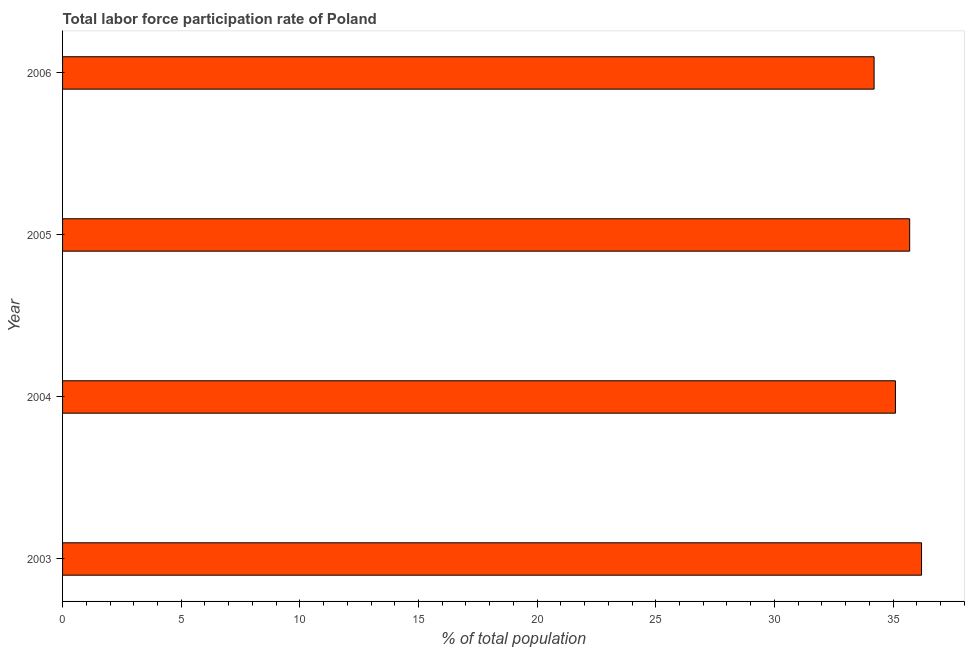Does the graph contain grids?
Offer a very short reply. No. What is the title of the graph?
Your answer should be compact. Total labor force participation rate of Poland. What is the label or title of the X-axis?
Your answer should be very brief. % of total population. What is the label or title of the Y-axis?
Your answer should be very brief. Year. What is the total labor force participation rate in 2003?
Offer a very short reply. 36.2. Across all years, what is the maximum total labor force participation rate?
Your response must be concise. 36.2. Across all years, what is the minimum total labor force participation rate?
Give a very brief answer. 34.2. In which year was the total labor force participation rate maximum?
Make the answer very short. 2003. What is the sum of the total labor force participation rate?
Make the answer very short. 141.2. What is the average total labor force participation rate per year?
Provide a succinct answer. 35.3. What is the median total labor force participation rate?
Provide a succinct answer. 35.4. Do a majority of the years between 2003 and 2005 (inclusive) have total labor force participation rate greater than 9 %?
Ensure brevity in your answer.  Yes. What is the ratio of the total labor force participation rate in 2005 to that in 2006?
Your answer should be very brief. 1.04. Is the total labor force participation rate in 2005 less than that in 2006?
Offer a terse response. No. Is the difference between the total labor force participation rate in 2003 and 2004 greater than the difference between any two years?
Provide a short and direct response. No. In how many years, is the total labor force participation rate greater than the average total labor force participation rate taken over all years?
Offer a terse response. 2. Are all the bars in the graph horizontal?
Offer a very short reply. Yes. What is the difference between two consecutive major ticks on the X-axis?
Offer a very short reply. 5. Are the values on the major ticks of X-axis written in scientific E-notation?
Keep it short and to the point. No. What is the % of total population of 2003?
Offer a very short reply. 36.2. What is the % of total population in 2004?
Ensure brevity in your answer.  35.1. What is the % of total population in 2005?
Ensure brevity in your answer.  35.7. What is the % of total population of 2006?
Your answer should be very brief. 34.2. What is the difference between the % of total population in 2003 and 2005?
Provide a short and direct response. 0.5. What is the difference between the % of total population in 2004 and 2005?
Your answer should be compact. -0.6. What is the difference between the % of total population in 2005 and 2006?
Ensure brevity in your answer.  1.5. What is the ratio of the % of total population in 2003 to that in 2004?
Your response must be concise. 1.03. What is the ratio of the % of total population in 2003 to that in 2006?
Your response must be concise. 1.06. What is the ratio of the % of total population in 2004 to that in 2005?
Make the answer very short. 0.98. What is the ratio of the % of total population in 2004 to that in 2006?
Make the answer very short. 1.03. What is the ratio of the % of total population in 2005 to that in 2006?
Provide a short and direct response. 1.04. 